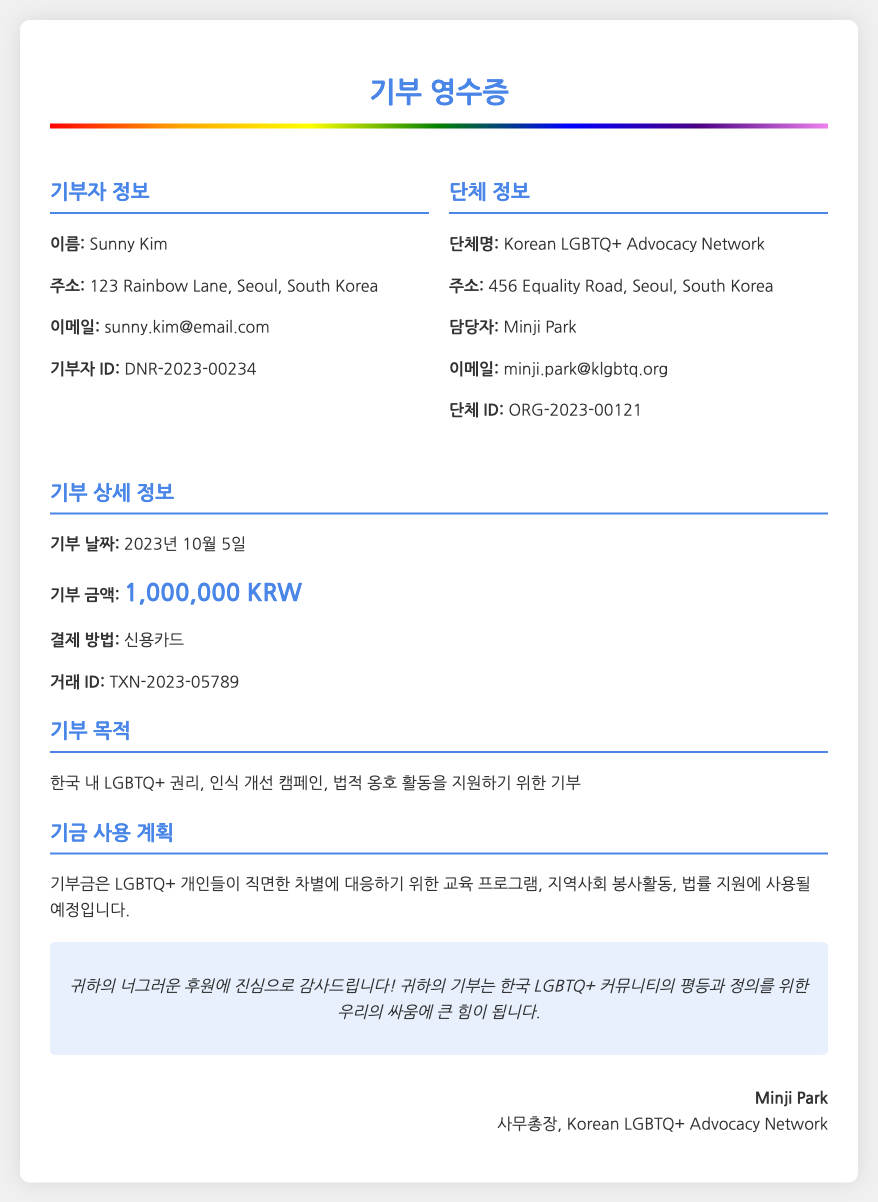What is the donor's name? The donor's name is provided in the "기부자 정보" section.
Answer: Sunny Kim What is the donation amount? The donation amount is mentioned in the "기부 상세 정보" section.
Answer: 1,000,000 KRW What is the purpose of the donation? The purpose of the donation is described in the "기부 목적" section.
Answer: 한국 내 LGBTQ+ 권리, 인식 개선 캠페인, 법적 옹호 활동을 지원하기 위한 기부 Who is the contact person for the organization? The contact person for the organization is listed in the "단체 정보" section.
Answer: Minji Park When was the donation made? The donation date is specified in the "기부 상세 정보" section.
Answer: 2023년 10월 5일 What method was used for the donation? The payment method is provided in the "기부 상세 정보" section.
Answer: 신용카드 What will the funds be used for? The planned use of the funds is explained in the "기금 사용 계획" section.
Answer: 교육 프로그램, 지역사회 봉사활동, 법률 지원 What is the transaction ID? The transaction ID is found in the "기부 상세 정보" section.
Answer: TXN-2023-05789 What organization is the donation made to? The organization receiving the donation is identified in the "단체 정보" section.
Answer: Korean LGBTQ+ Advocacy Network 